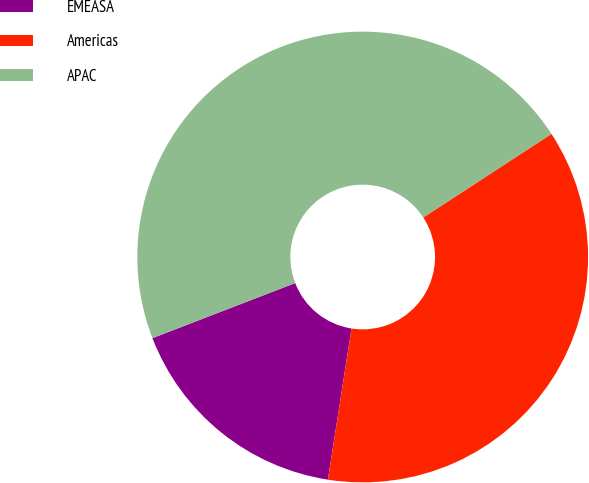<chart> <loc_0><loc_0><loc_500><loc_500><pie_chart><fcel>EMEASA<fcel>Americas<fcel>APAC<nl><fcel>16.67%<fcel>36.67%<fcel>46.67%<nl></chart> 